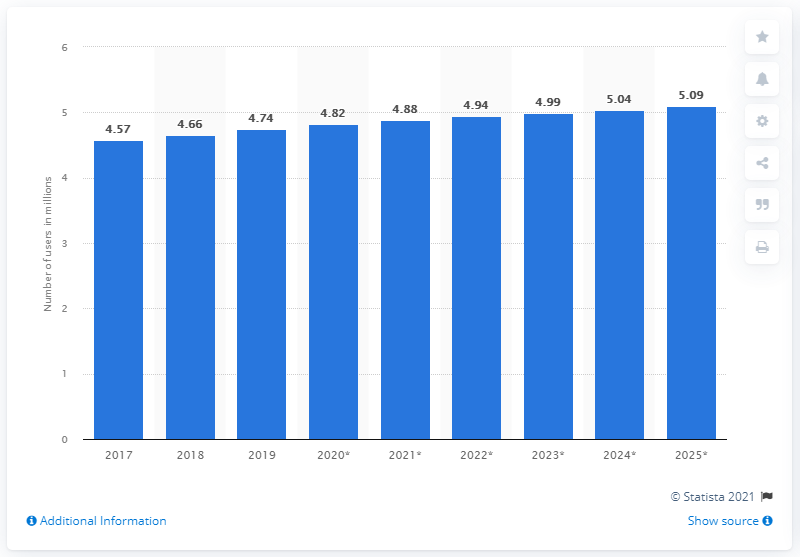Mention a couple of crucial points in this snapshot. In 2019, there were approximately 4.74 million Facebook users in Singapore. By 2025, it is projected that there will be approximately 5.09 million Facebook users in Singapore. 